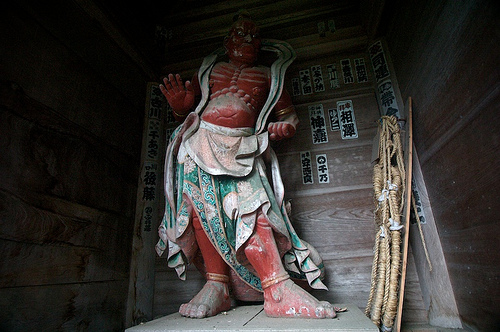<image>
Can you confirm if the skirt is on the floor? No. The skirt is not positioned on the floor. They may be near each other, but the skirt is not supported by or resting on top of the floor. 